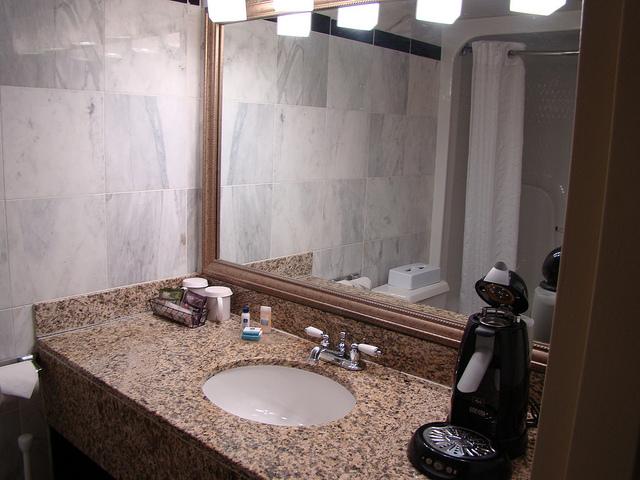What type of wall covering is there?
Concise answer only. Tile. Is the mirror big?
Keep it brief. Yes. What is this room?
Short answer required. Bathroom. 